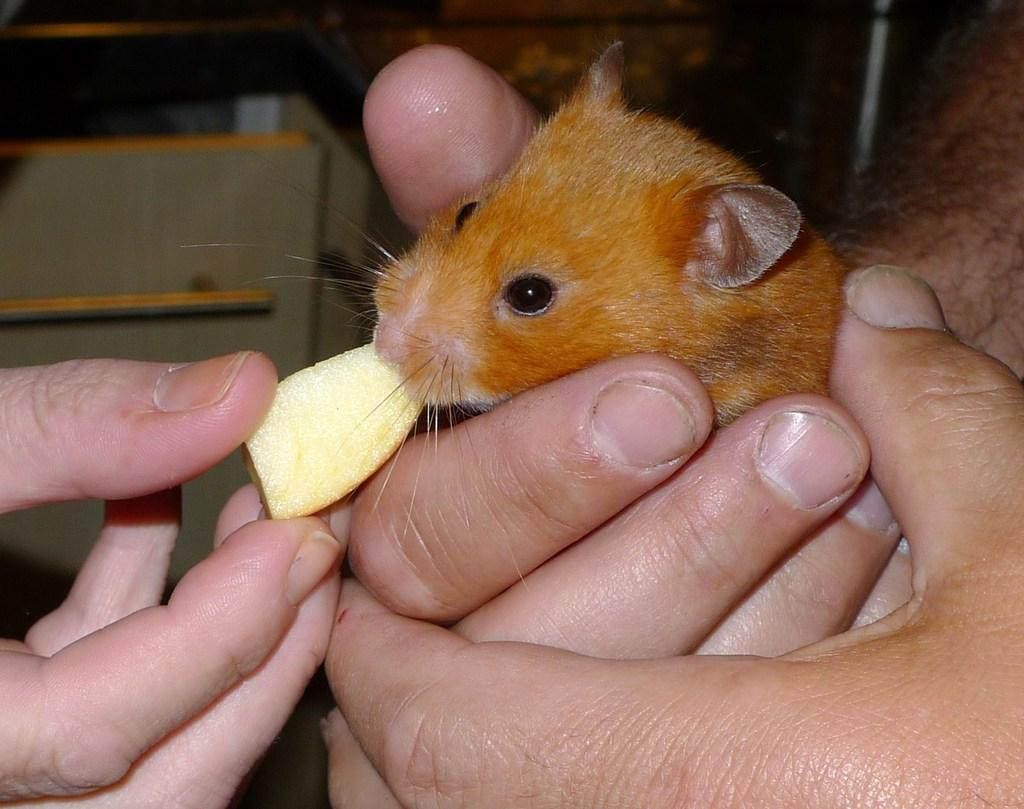What is the main subject of the image? There is a person in the image. What is the person holding in the image? The person is holding a rat. What is the rat doing in the image? The rat is eating an apple. What type of thread is the rat using to sew a letter in the image? There is no thread or letter present in the image; the rat is simply eating an apple. 